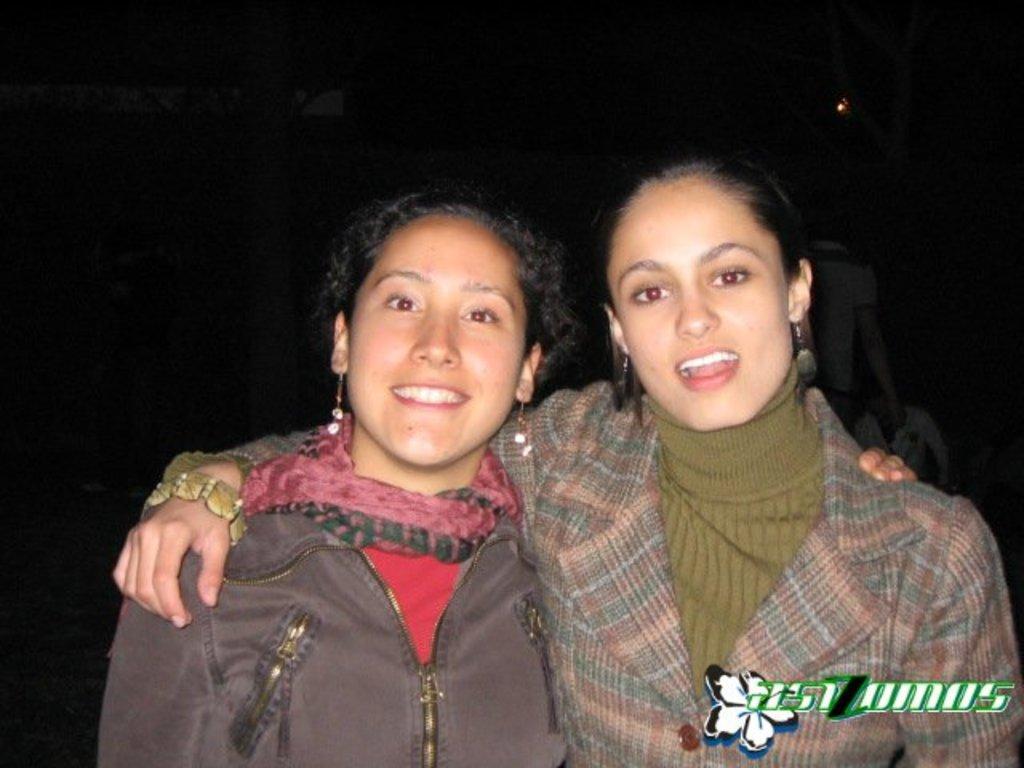How would you summarize this image in a sentence or two? In the center of the image we can see two ladies standing and smiling. In the background there are people. 